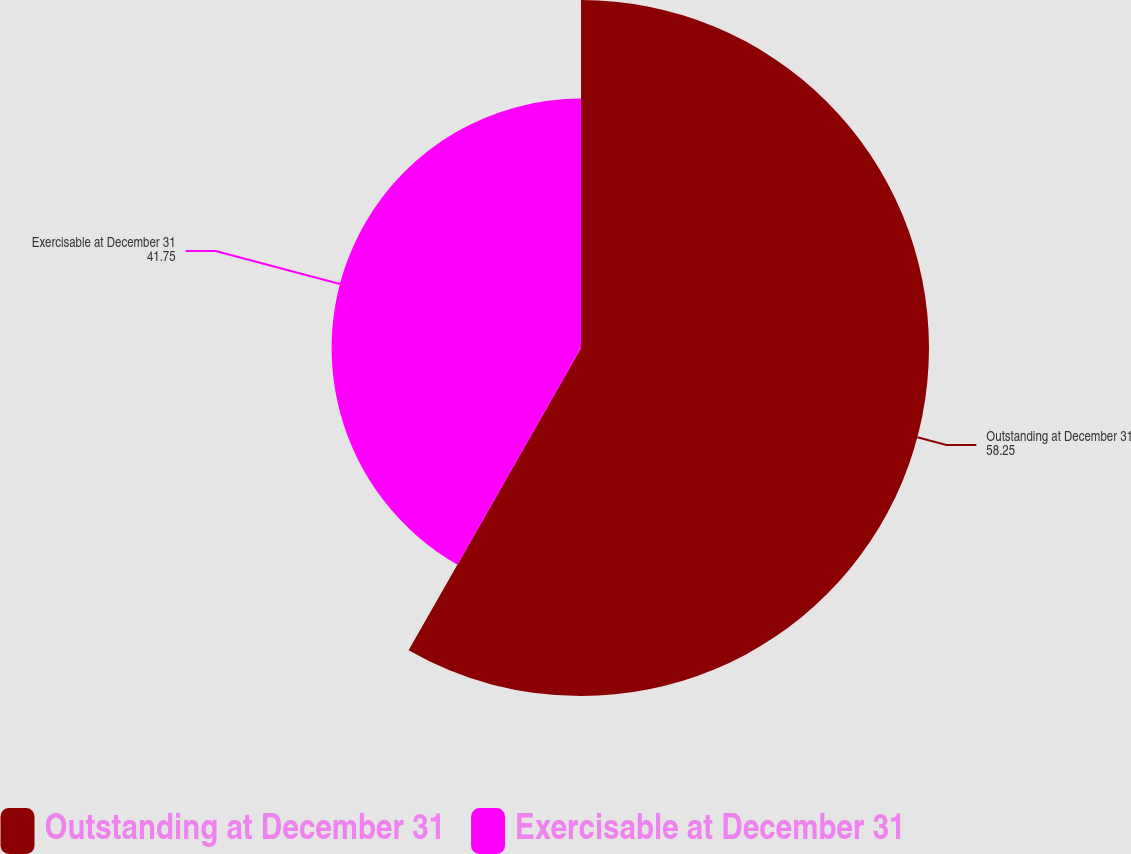Convert chart to OTSL. <chart><loc_0><loc_0><loc_500><loc_500><pie_chart><fcel>Outstanding at December 31<fcel>Exercisable at December 31<nl><fcel>58.25%<fcel>41.75%<nl></chart> 